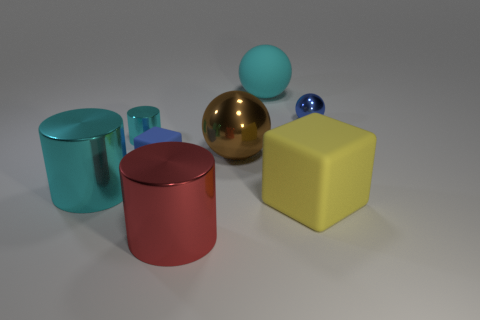Subtract all cyan cylinders. Subtract all green spheres. How many cylinders are left? 1 Add 1 brown spheres. How many objects exist? 9 Subtract all spheres. How many objects are left? 5 Add 7 red cylinders. How many red cylinders are left? 8 Add 4 yellow matte blocks. How many yellow matte blocks exist? 5 Subtract 0 red balls. How many objects are left? 8 Subtract all large brown matte things. Subtract all blue metallic objects. How many objects are left? 7 